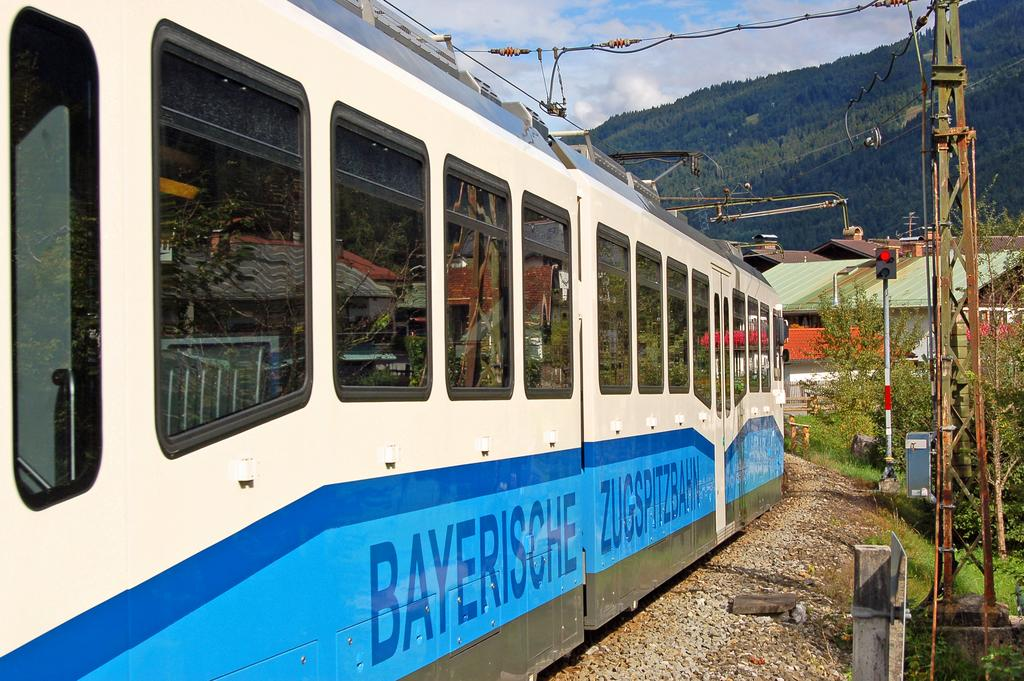<image>
Describe the image concisely. the word Bayersche on a train during the day 